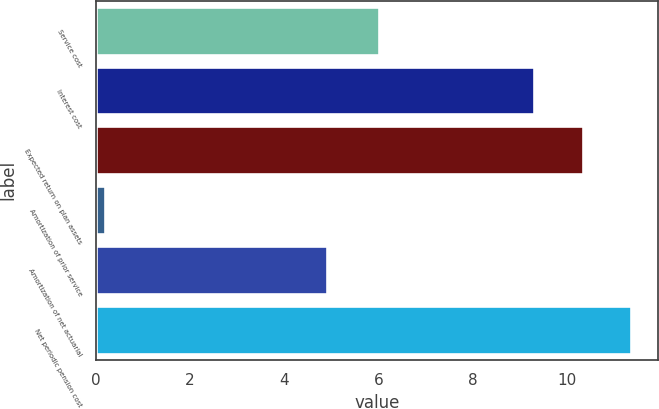Convert chart to OTSL. <chart><loc_0><loc_0><loc_500><loc_500><bar_chart><fcel>Service cost<fcel>Interest cost<fcel>Expected return on plan assets<fcel>Amortization of prior service<fcel>Amortization of net actuarial<fcel>Net periodic pension cost<nl><fcel>6<fcel>9.3<fcel>10.33<fcel>0.2<fcel>4.9<fcel>11.36<nl></chart> 